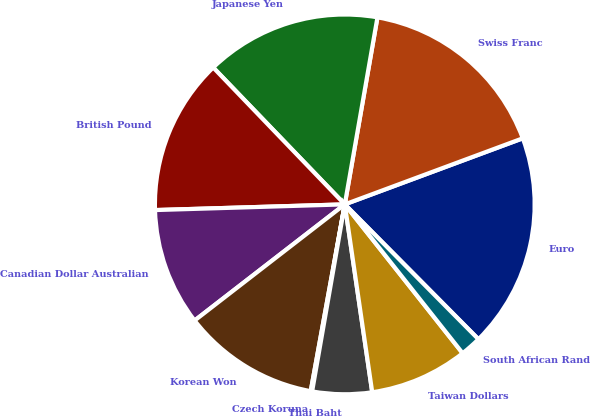Convert chart to OTSL. <chart><loc_0><loc_0><loc_500><loc_500><pie_chart><fcel>Euro<fcel>Swiss Franc<fcel>Japanese Yen<fcel>British Pound<fcel>Canadian Dollar Australian<fcel>Korean Won<fcel>Czech Koruna<fcel>Thai Baht<fcel>Taiwan Dollars<fcel>South African Rand<nl><fcel>18.23%<fcel>16.59%<fcel>14.94%<fcel>13.29%<fcel>10.0%<fcel>11.65%<fcel>0.12%<fcel>5.06%<fcel>8.35%<fcel>1.77%<nl></chart> 